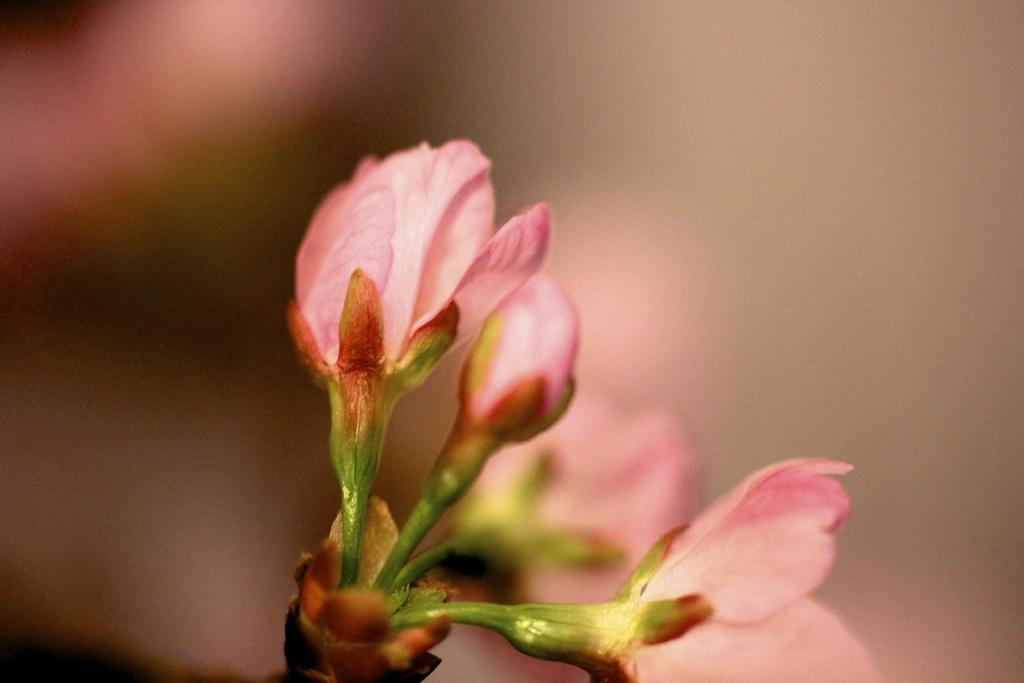What type of flowers are in the middle of the image? There are pink flowers in the middle of the image. Can you describe the stage of development of one of the flowers? There is a flower bud in the image. What is the appearance of the background in the image? The background of the image is blurred. How does the person in the image adjust their self-esteem while walking on the sidewalk? There is no person present in the image, and therefore no adjustment of self-esteem or walking on a sidewalk can be observed. 